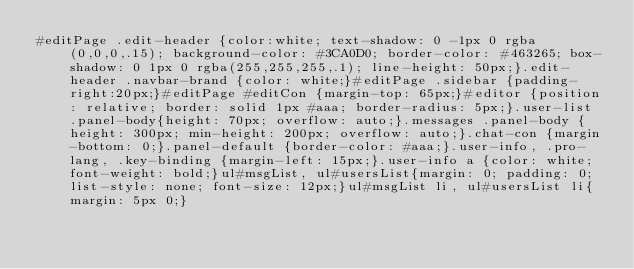Convert code to text. <code><loc_0><loc_0><loc_500><loc_500><_CSS_>#editPage .edit-header {color:white; text-shadow: 0 -1px 0 rgba(0,0,0,.15); background-color: #3CA0D0; border-color: #463265; box-shadow: 0 1px 0 rgba(255,255,255,.1); line-height: 50px;}.edit-header .navbar-brand {color: white;}#editPage .sidebar {padding-right:20px;}#editPage #editCon {margin-top: 65px;}#editor {position: relative; border: solid 1px #aaa; border-radius: 5px;}.user-list .panel-body{height: 70px; overflow: auto;}.messages .panel-body {height: 300px; min-height: 200px; overflow: auto;}.chat-con {margin-bottom: 0;}.panel-default {border-color: #aaa;}.user-info, .pro-lang, .key-binding {margin-left: 15px;}.user-info a {color: white; font-weight: bold;}ul#msgList, ul#usersList{margin: 0; padding: 0; list-style: none; font-size: 12px;}ul#msgList li, ul#usersList li{margin: 5px 0;}</code> 